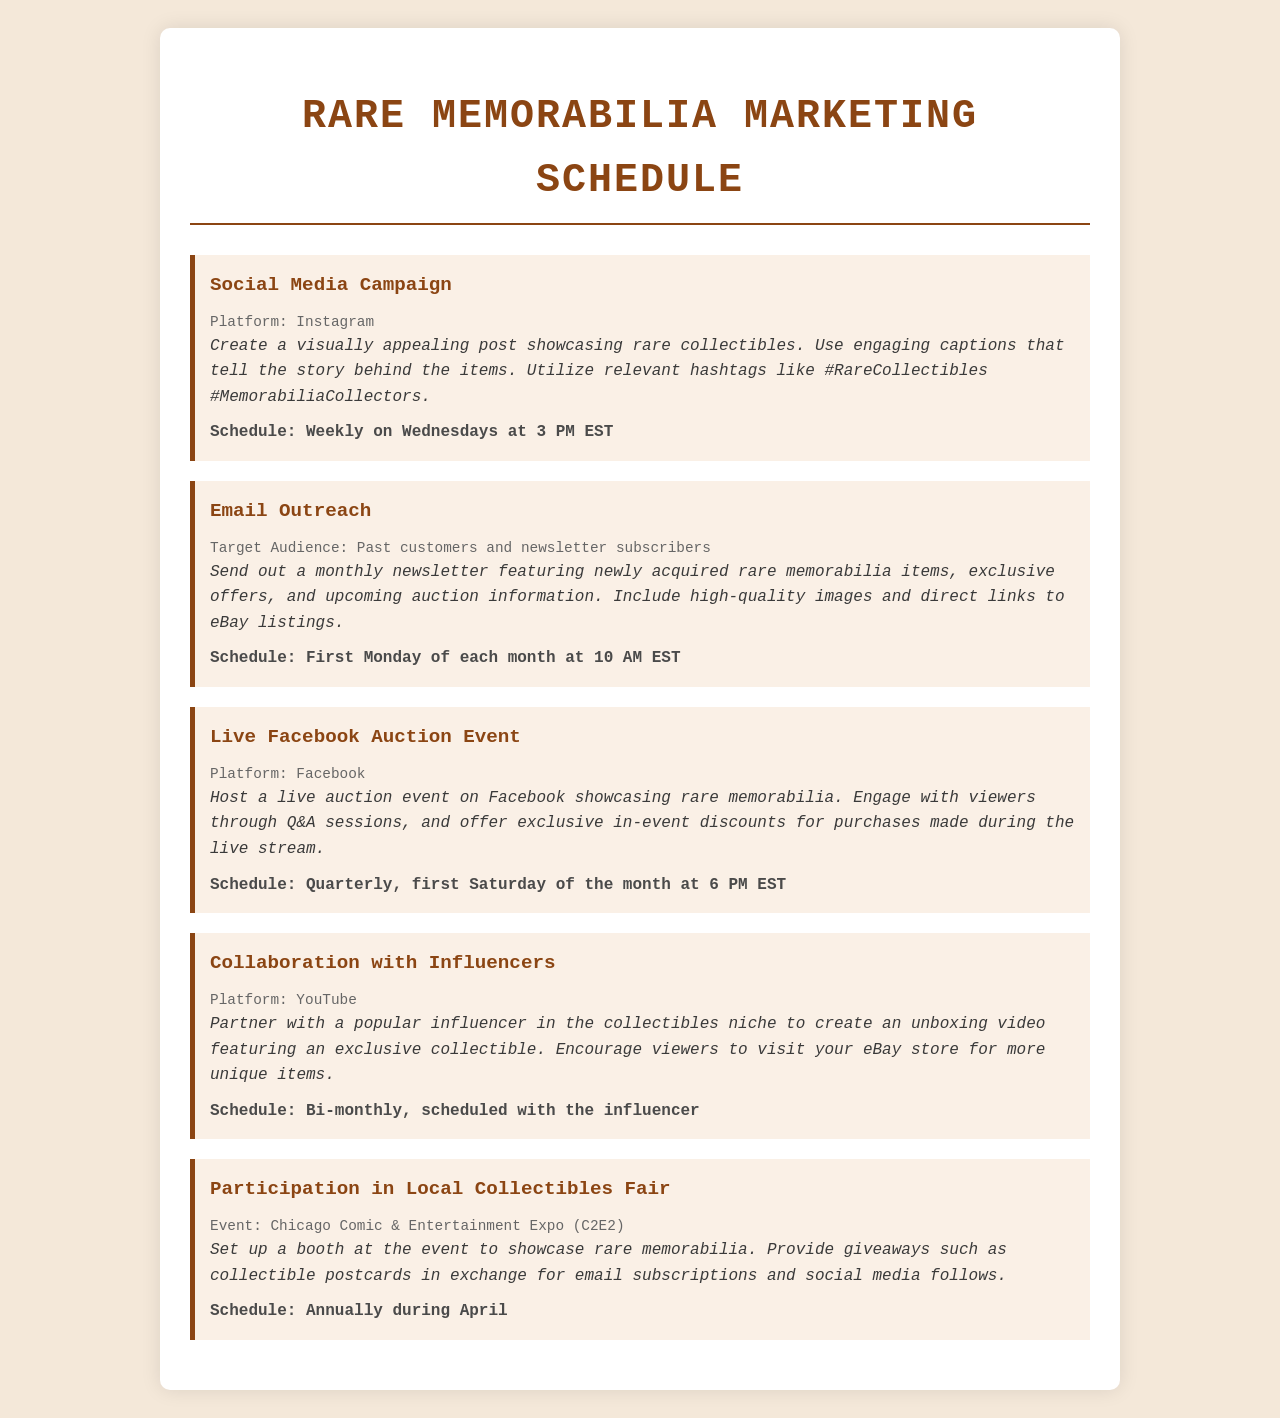What is the frequency of the Social Media Campaign? The Social Media Campaign is scheduled to occur weekly on Wednesdays.
Answer: Weekly on Wednesdays Who is the target audience for the Email Outreach? The target audience for the Email Outreach consists of past customers and newsletter subscribers.
Answer: Past customers and newsletter subscribers What is the platform for the Live Facebook Auction Event? The platform used for the Live Facebook Auction Event is Facebook.
Answer: Facebook When is the Participation in Local Collectibles Fair scheduled? The Participation in Local Collectibles Fair is scheduled annually during April.
Answer: Annually during April How often will the Collaboration with Influencers take place? The Collaboration with Influencers is scheduled to occur bi-monthly.
Answer: Bi-monthly What activity is scheduled for the first Saturday of the month? The activity scheduled for the first Saturday of the month is the Live Facebook Auction Event.
Answer: Live Facebook Auction Event What type of items will be featured in the Email Outreach? The Email Outreach will feature newly acquired rare memorabilia items.
Answer: Newly acquired rare memorabilia items What is a benefit offered during the Live Facebook Auction Event? A benefit offered during the Live Facebook Auction Event is exclusive in-event discounts for purchases made during the live stream.
Answer: Exclusive in-event discounts What type of materials will be provided at the collectibles fair? The collectibles fair will provide giveaways such as collectible postcards.
Answer: Collectible postcards 